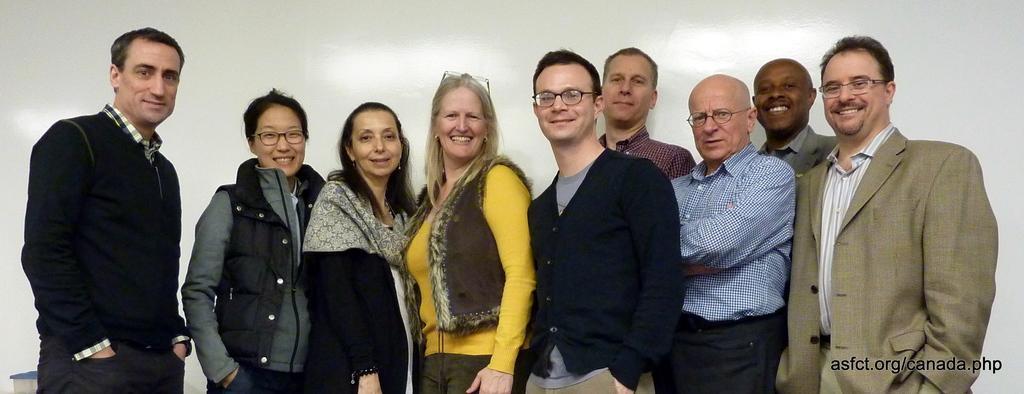Could you give a brief overview of what you see in this image? In this picture there are group of people standing and smiling. At the back it looks like a wall. At the bottom right there is text. 